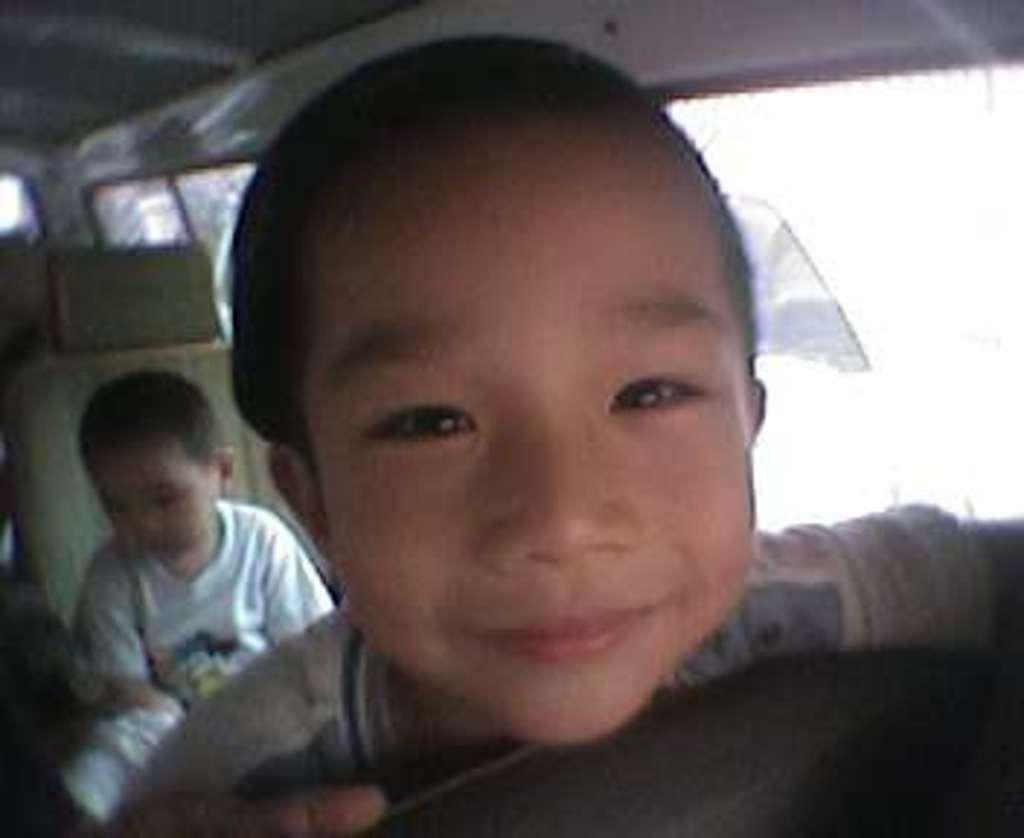Who is present in the image? There is a boy in the image. What is the boy's expression? The boy is smiling. Where was the image likely taken? The image appears to be taken inside a vehicle. What type of rice is being served in the image? There is no rice present in the image; it features a boy smiling inside a vehicle. What color is the marble on the boy's shirt in the image? There is no marble or shirt visible in the image, as it only shows a boy smiling inside a vehicle. 